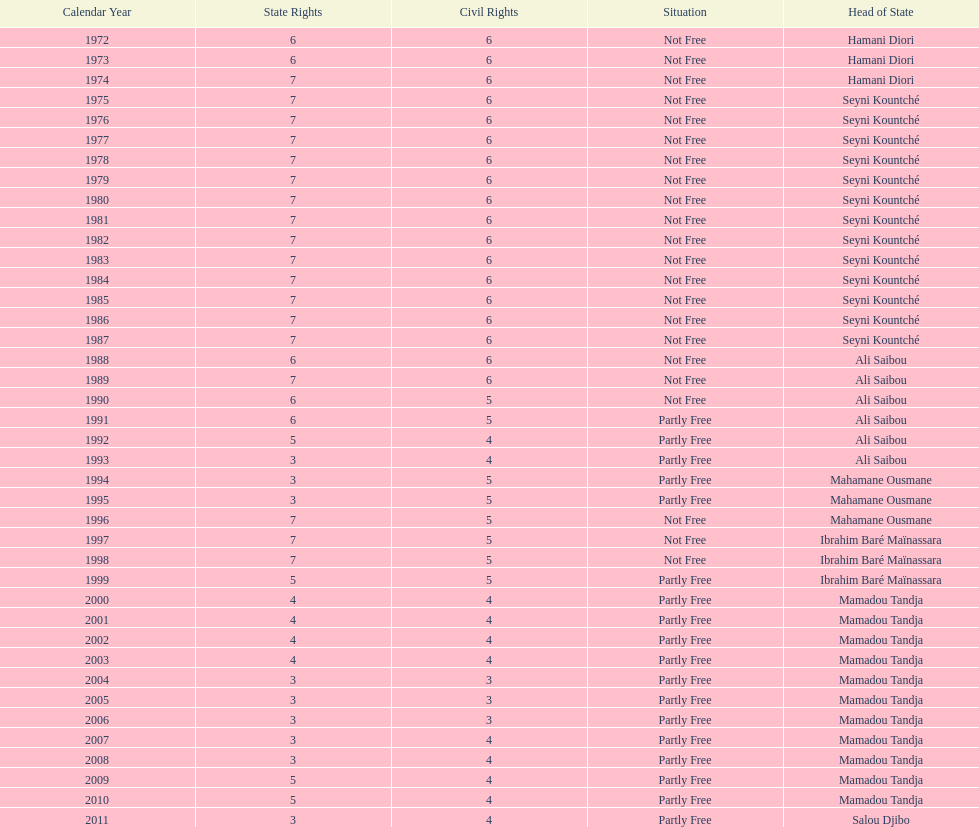How many years was it before the first partly free status? 18. 